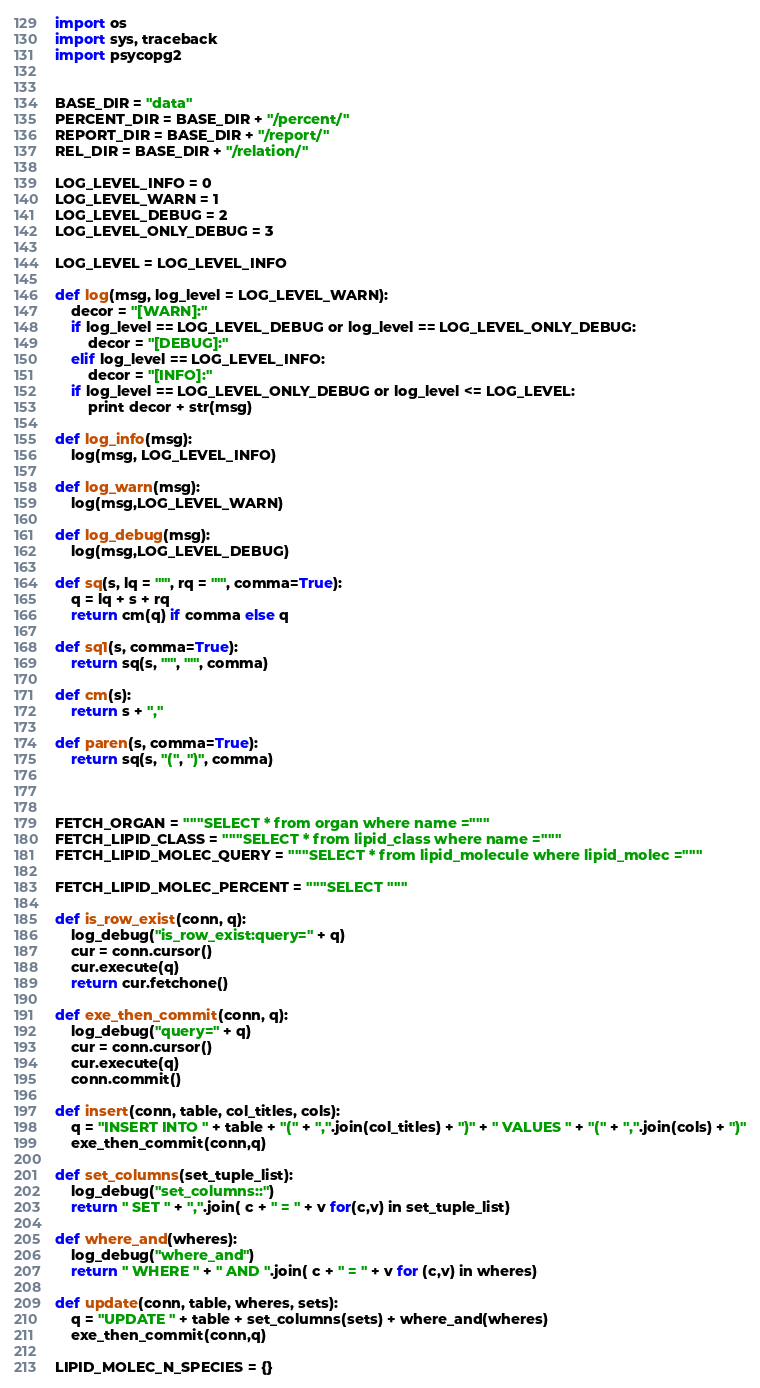Convert code to text. <code><loc_0><loc_0><loc_500><loc_500><_Python_>
import os
import sys, traceback
import psycopg2


BASE_DIR = "data"
PERCENT_DIR = BASE_DIR + "/percent/"
REPORT_DIR = BASE_DIR + "/report/"
REL_DIR = BASE_DIR + "/relation/"

LOG_LEVEL_INFO = 0
LOG_LEVEL_WARN = 1
LOG_LEVEL_DEBUG = 2
LOG_LEVEL_ONLY_DEBUG = 3

LOG_LEVEL = LOG_LEVEL_INFO

def log(msg, log_level = LOG_LEVEL_WARN):
    decor = "[WARN]:"
    if log_level == LOG_LEVEL_DEBUG or log_level == LOG_LEVEL_ONLY_DEBUG:
        decor = "[DEBUG]:"
    elif log_level == LOG_LEVEL_INFO:
        decor = "[INFO]:"
    if log_level == LOG_LEVEL_ONLY_DEBUG or log_level <= LOG_LEVEL:
        print decor + str(msg)

def log_info(msg):
    log(msg, LOG_LEVEL_INFO)

def log_warn(msg):
    log(msg,LOG_LEVEL_WARN)

def log_debug(msg):
    log(msg,LOG_LEVEL_DEBUG)

def sq(s, lq = "'", rq = "'", comma=True):
    q = lq + s + rq
    return cm(q) if comma else q

def sq1(s, comma=True):
    return sq(s, "'", "'", comma)

def cm(s):
    return s + ","

def paren(s, comma=True):
    return sq(s, "(", ")", comma)



FETCH_ORGAN = """SELECT * from organ where name ="""
FETCH_LIPID_CLASS = """SELECT * from lipid_class where name ="""
FETCH_LIPID_MOLEC_QUERY = """SELECT * from lipid_molecule where lipid_molec ="""

FETCH_LIPID_MOLEC_PERCENT = """SELECT """

def is_row_exist(conn, q):
    log_debug("is_row_exist:query=" + q)
    cur = conn.cursor()
    cur.execute(q)
    return cur.fetchone()

def exe_then_commit(conn, q):
    log_debug("query=" + q)
    cur = conn.cursor()
    cur.execute(q)
    conn.commit()

def insert(conn, table, col_titles, cols):
    q = "INSERT INTO " + table + "(" + ",".join(col_titles) + ")" + " VALUES " + "(" + ",".join(cols) + ")"
    exe_then_commit(conn,q)

def set_columns(set_tuple_list):
    log_debug("set_columns::")
    return " SET " + ",".join( c + " = " + v for(c,v) in set_tuple_list)

def where_and(wheres):
    log_debug("where_and")
    return " WHERE " + " AND ".join( c + " = " + v for (c,v) in wheres)

def update(conn, table, wheres, sets):
    q = "UPDATE " + table + set_columns(sets) + where_and(wheres)
    exe_then_commit(conn,q)

LIPID_MOLEC_N_SPECIES = {}
</code> 